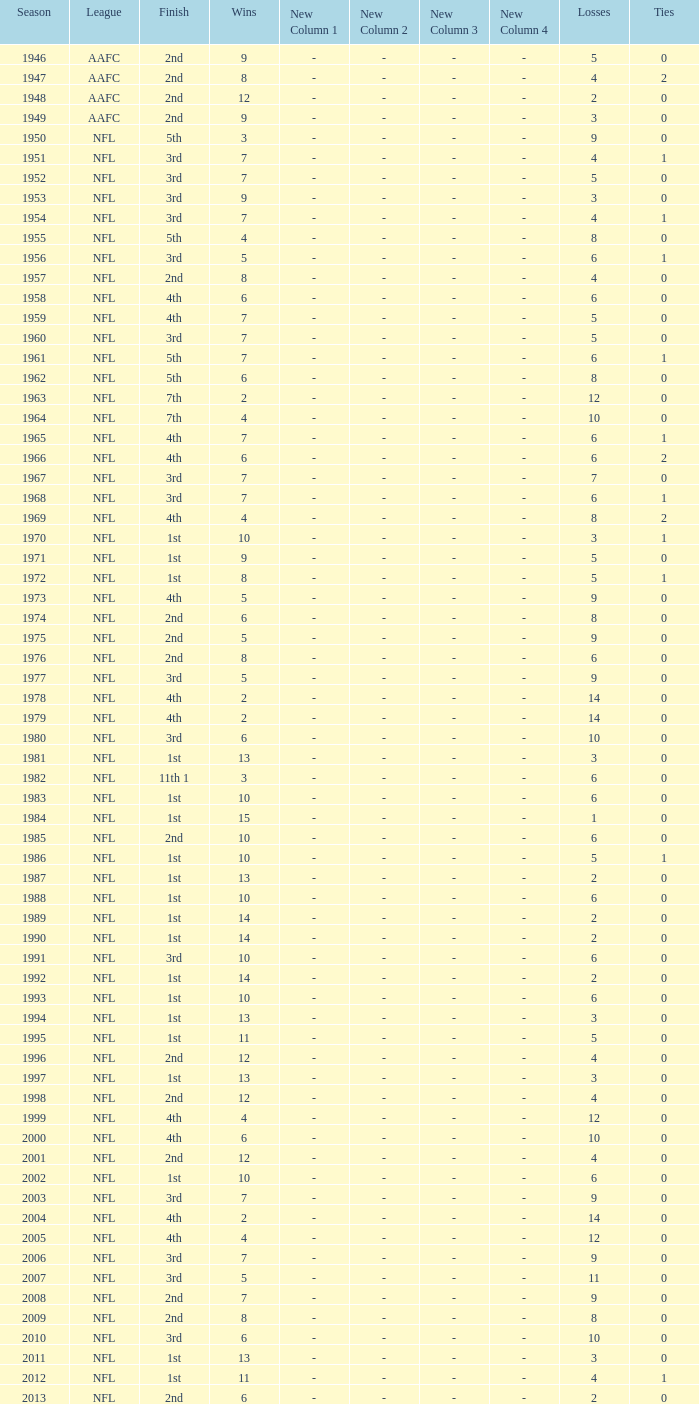With under 15 wins and fewer than 2 losses, what is the lowest possible number of ties in the nfl? None. 